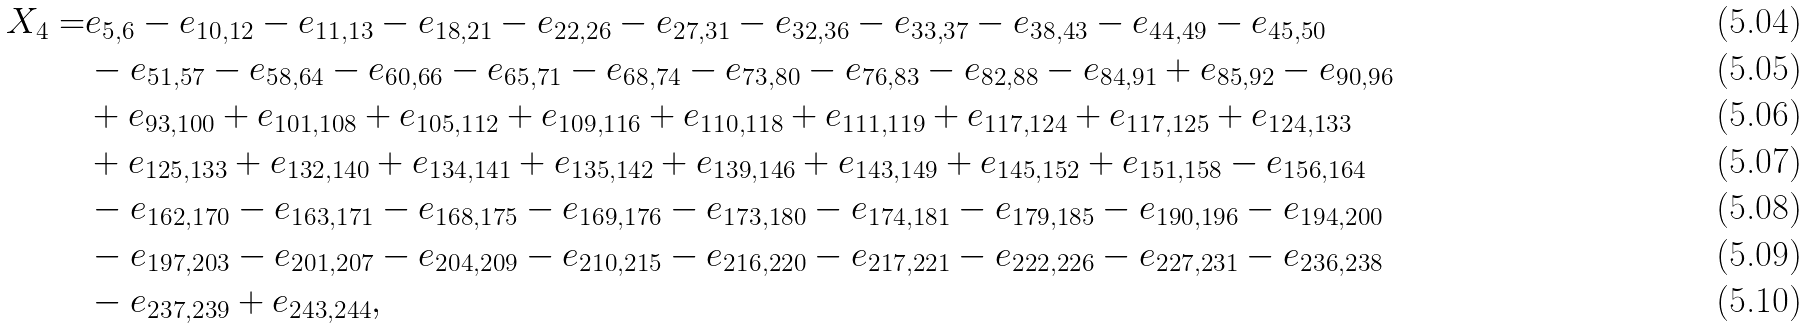<formula> <loc_0><loc_0><loc_500><loc_500>X _ { 4 } = & e _ { 5 , 6 } - e _ { 1 0 , 1 2 } - e _ { 1 1 , 1 3 } - e _ { 1 8 , 2 1 } - e _ { 2 2 , 2 6 } - e _ { 2 7 , 3 1 } - e _ { 3 2 , 3 6 } - e _ { 3 3 , 3 7 } - e _ { 3 8 , 4 3 } - e _ { 4 4 , 4 9 } - e _ { 4 5 , 5 0 } \\ & - e _ { 5 1 , 5 7 } - e _ { 5 8 , 6 4 } - e _ { 6 0 , 6 6 } - e _ { 6 5 , 7 1 } - e _ { 6 8 , 7 4 } - e _ { 7 3 , 8 0 } - e _ { 7 6 , 8 3 } - e _ { 8 2 , 8 8 } - e _ { 8 4 , 9 1 } + e _ { 8 5 , 9 2 } - e _ { 9 0 , 9 6 } \\ & + e _ { 9 3 , 1 0 0 } + e _ { 1 0 1 , 1 0 8 } + e _ { 1 0 5 , 1 1 2 } + e _ { 1 0 9 , 1 1 6 } + e _ { 1 1 0 , 1 1 8 } + e _ { 1 1 1 , 1 1 9 } + e _ { 1 1 7 , 1 2 4 } + e _ { 1 1 7 , 1 2 5 } + e _ { 1 2 4 , 1 3 3 } \\ & + e _ { 1 2 5 , 1 3 3 } + e _ { 1 3 2 , 1 4 0 } + e _ { 1 3 4 , 1 4 1 } + e _ { 1 3 5 , 1 4 2 } + e _ { 1 3 9 , 1 4 6 } + e _ { 1 4 3 , 1 4 9 } + e _ { 1 4 5 , 1 5 2 } + e _ { 1 5 1 , 1 5 8 } - e _ { 1 5 6 , 1 6 4 } \\ & - e _ { 1 6 2 , 1 7 0 } - e _ { 1 6 3 , 1 7 1 } - e _ { 1 6 8 , 1 7 5 } - e _ { 1 6 9 , 1 7 6 } - e _ { 1 7 3 , 1 8 0 } - e _ { 1 7 4 , 1 8 1 } - e _ { 1 7 9 , 1 8 5 } - e _ { 1 9 0 , 1 9 6 } - e _ { 1 9 4 , 2 0 0 } \\ & - e _ { 1 9 7 , 2 0 3 } - e _ { 2 0 1 , 2 0 7 } - e _ { 2 0 4 , 2 0 9 } - e _ { 2 1 0 , 2 1 5 } - e _ { 2 1 6 , 2 2 0 } - e _ { 2 1 7 , 2 2 1 } - e _ { 2 2 2 , 2 2 6 } - e _ { 2 2 7 , 2 3 1 } - e _ { 2 3 6 , 2 3 8 } \\ & - e _ { 2 3 7 , 2 3 9 } + e _ { 2 4 3 , 2 4 4 } ,</formula> 